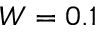Convert formula to latex. <formula><loc_0><loc_0><loc_500><loc_500>W = 0 . 1</formula> 